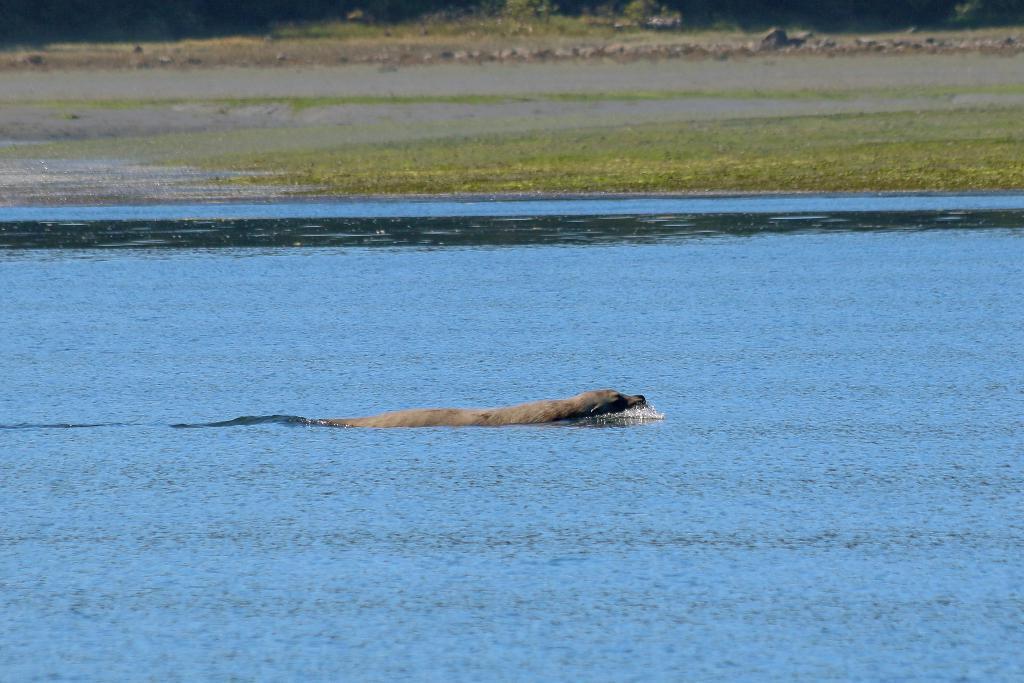Could you give a brief overview of what you see in this image? In this image we can see an animal in the water. 